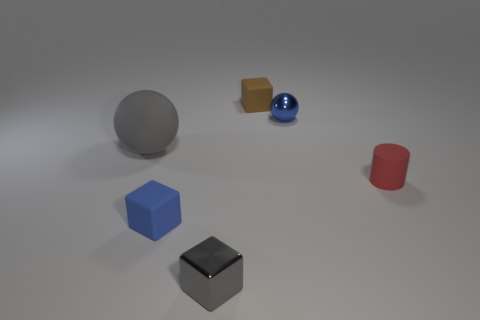Add 2 small brown blocks. How many objects exist? 8 Subtract all balls. How many objects are left? 4 Add 5 gray objects. How many gray objects exist? 7 Subtract 0 yellow cylinders. How many objects are left? 6 Subtract all gray shiny blocks. Subtract all big gray matte balls. How many objects are left? 4 Add 6 large matte spheres. How many large matte spheres are left? 7 